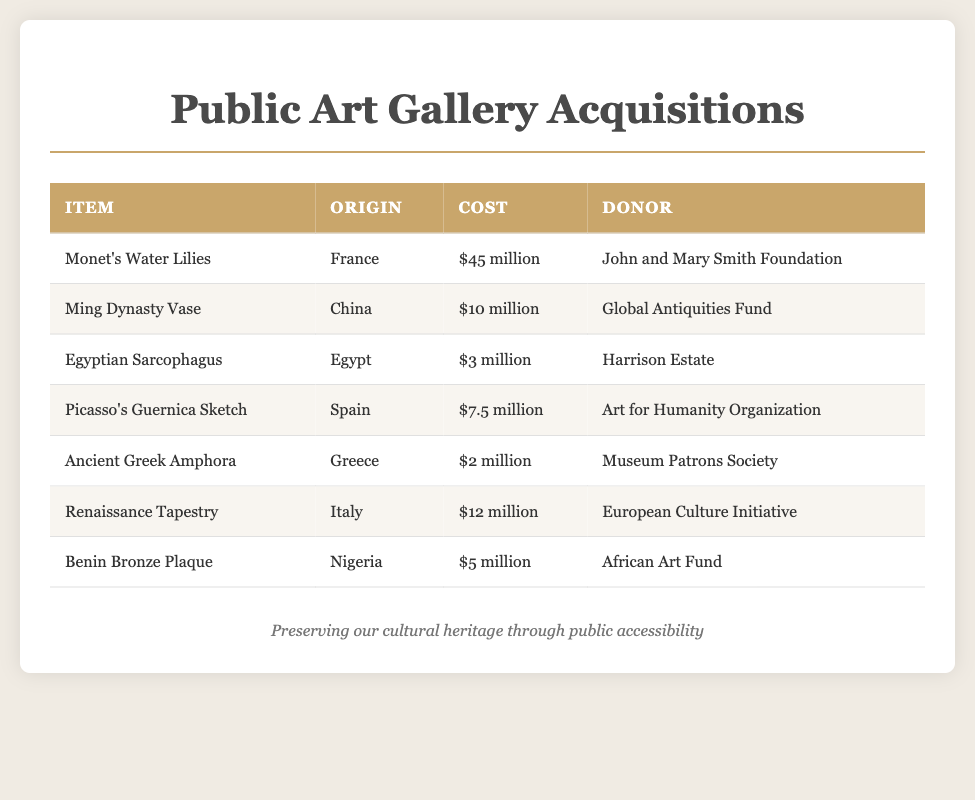What is the item with the highest cost? The item with the highest cost is identified by comparing the costs listed. Monet's Water Lilies is $45 million.
Answer: Monet's Water Lilies Who donated the Ming Dynasty Vase? The donor of the Ming Dynasty Vase can be found in the donor column corresponding to that item. The donor is the Global Antiquities Fund.
Answer: Global Antiquities Fund What is the origin of the Egyptian Sarcophagus? The origin of the Egyptian Sarcophagus is stated in the origin column corresponding to that item. The origin is Egypt.
Answer: Egypt How much did the Renaissance Tapestry cost? The cost of the Renaissance Tapestry is directly listed in the cost column. It costs $12 million.
Answer: $12 million Which item has a cost of $5 million? To find the item costing $5 million, look through the cost column and identify the corresponding item. The item is Benin Bronze Plaque.
Answer: Benin Bronze Plaque Which donor contributed the most expensive item? To answer this, check the donor related to the item with the highest cost, which is Monet's Water Lilies. The donor is John and Mary Smith Foundation.
Answer: John and Mary Smith Foundation How many items were listed in the acquisitions? Count the number of rows in the document's table besides the header, indicating the number of items listed. There are 7 items.
Answer: 7 What type of artifact is the item from Greece? The type of artifact from Greece is specified in the items column, which indicates it is an Ancient Greek Amphora.
Answer: Ancient Greek Amphora 